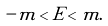<formula> <loc_0><loc_0><loc_500><loc_500>- m < E < m .</formula> 